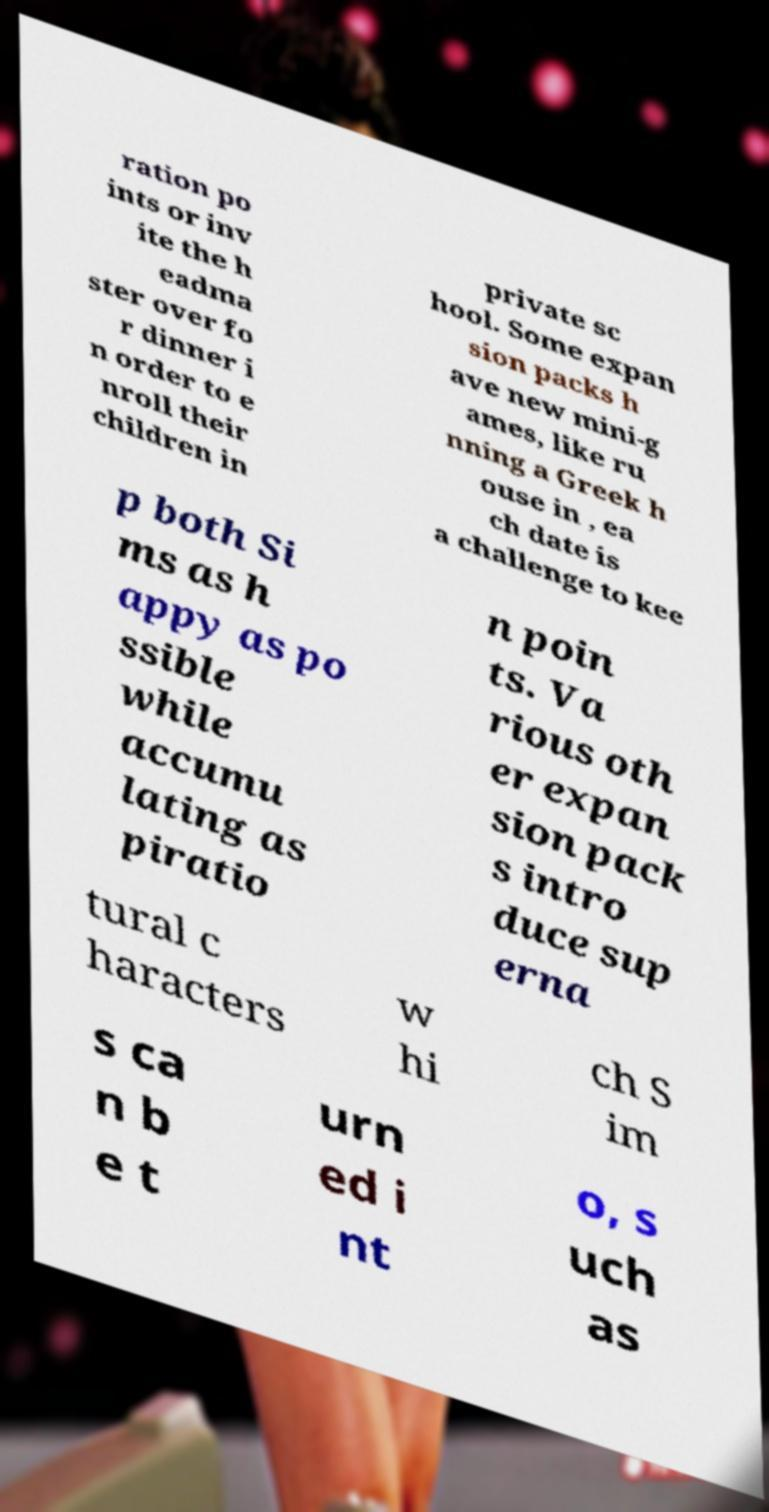Please identify and transcribe the text found in this image. ration po ints or inv ite the h eadma ster over fo r dinner i n order to e nroll their children in private sc hool. Some expan sion packs h ave new mini-g ames, like ru nning a Greek h ouse in , ea ch date is a challenge to kee p both Si ms as h appy as po ssible while accumu lating as piratio n poin ts. Va rious oth er expan sion pack s intro duce sup erna tural c haracters w hi ch S im s ca n b e t urn ed i nt o, s uch as 